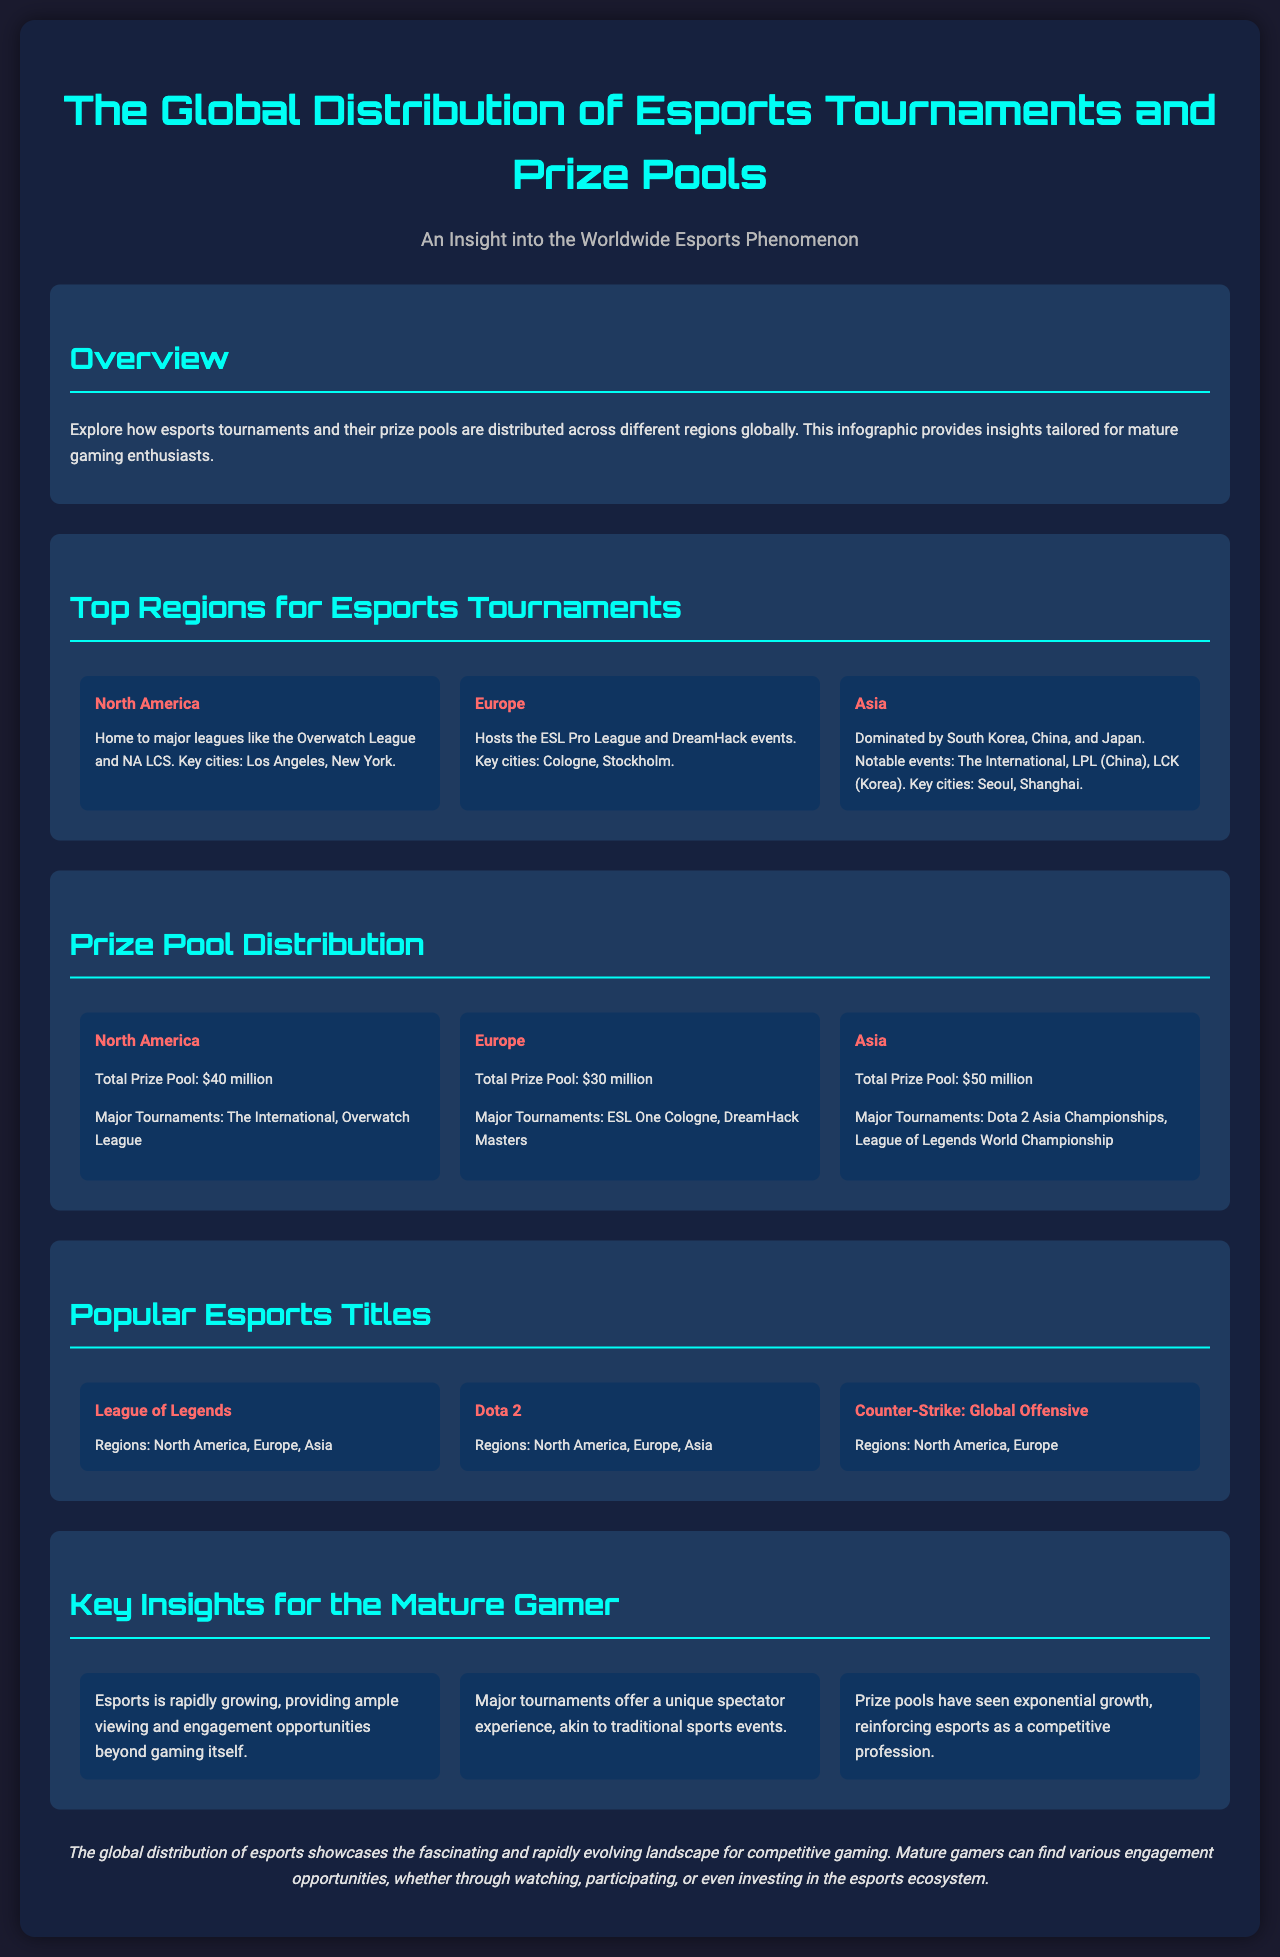What is the total prize pool for North America? The total prize pool for North America is explicitly stated in the document as $40 million.
Answer: $40 million Which region hosts the ESL Pro League? The document specifies that the ESL Pro League is hosted in Europe.
Answer: Europe What is the major tournament in Asia mentioned in the document? The document highlights "The International" as a major tournament in Asia.
Answer: The International How much is the total prize pool for Asia? The document states that the total prize pool for Asia is $50 million.
Answer: $50 million Which game is popular in both North America and Europe? The document lists "Counter-Strike: Global Offensive" as a popular game in North America and Europe.
Answer: Counter-Strike: Global Offensive What key insight mentions spectator experience? One of the insights states that major tournaments offer a unique spectator experience, akin to traditional sports events.
Answer: Unique spectator experience How many major tournaments are listed for Europe? The document specifies two major tournaments for Europe: ESL One Cologne and DreamHack Masters.
Answer: Two Which key cities are associated with North America? Los Angeles and New York are mentioned as key cities for North America in the document.
Answer: Los Angeles, New York What is the total prize pool for Europe? The total prize pool for Europe is explicitly stated in the document as $30 million.
Answer: $30 million 